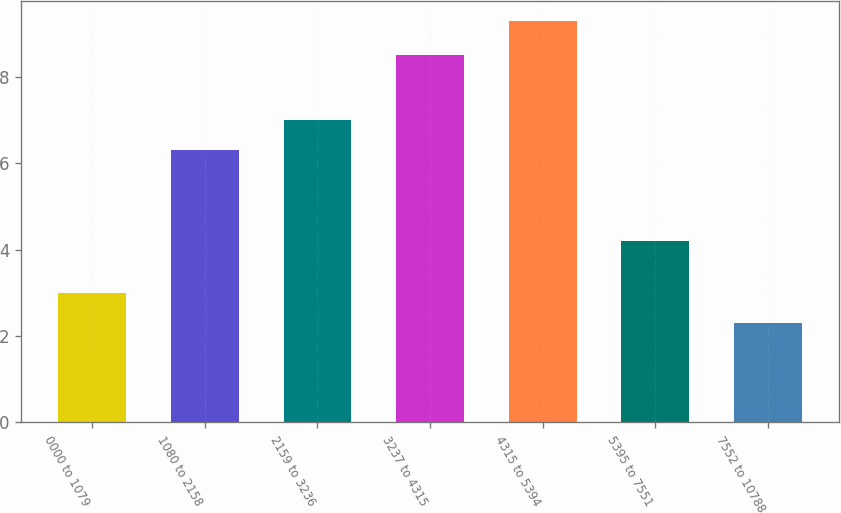Convert chart to OTSL. <chart><loc_0><loc_0><loc_500><loc_500><bar_chart><fcel>0000 to 1079<fcel>1080 to 2158<fcel>2159 to 3236<fcel>3237 to 4315<fcel>4315 to 5394<fcel>5395 to 7551<fcel>7552 to 10788<nl><fcel>3<fcel>6.3<fcel>7<fcel>8.5<fcel>9.3<fcel>4.2<fcel>2.3<nl></chart> 